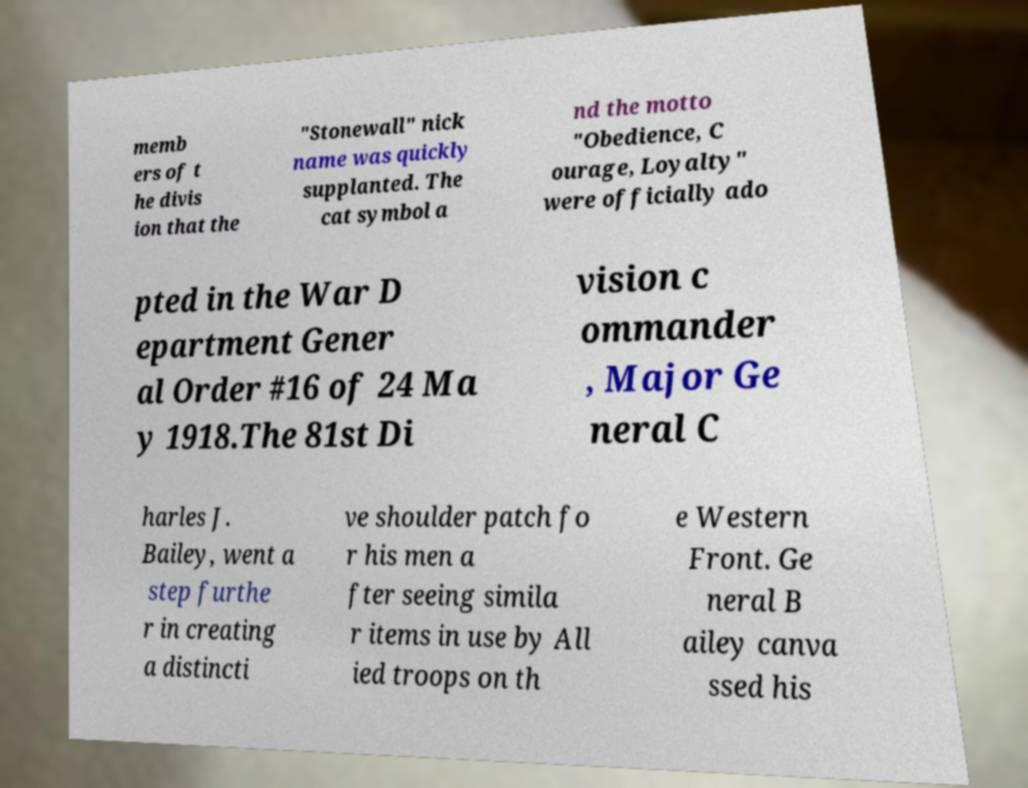I need the written content from this picture converted into text. Can you do that? memb ers of t he divis ion that the "Stonewall" nick name was quickly supplanted. The cat symbol a nd the motto "Obedience, C ourage, Loyalty" were officially ado pted in the War D epartment Gener al Order #16 of 24 Ma y 1918.The 81st Di vision c ommander , Major Ge neral C harles J. Bailey, went a step furthe r in creating a distincti ve shoulder patch fo r his men a fter seeing simila r items in use by All ied troops on th e Western Front. Ge neral B ailey canva ssed his 